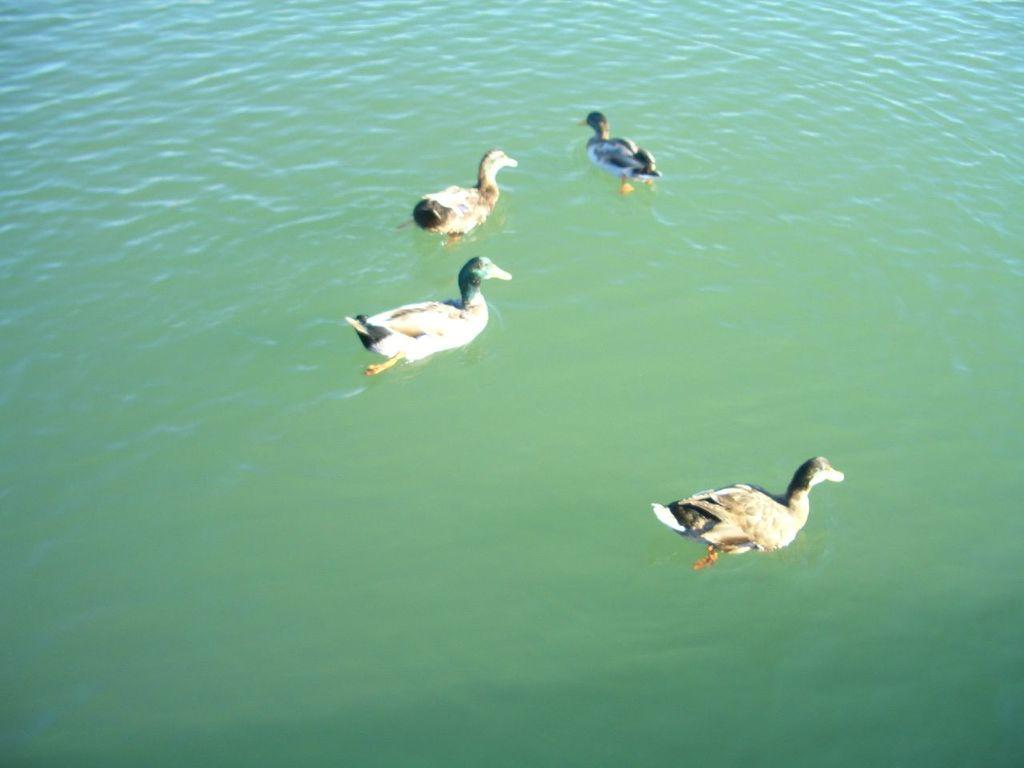What type of animals can be seen in the image? Birds can be seen in the image. Where are the birds located in the image? The birds are on water. Is there a ghost visible in the image? No, there is no ghost present in the image. Where is the meeting taking place in the image? There is no meeting depicted in the image; it features birds on water. 